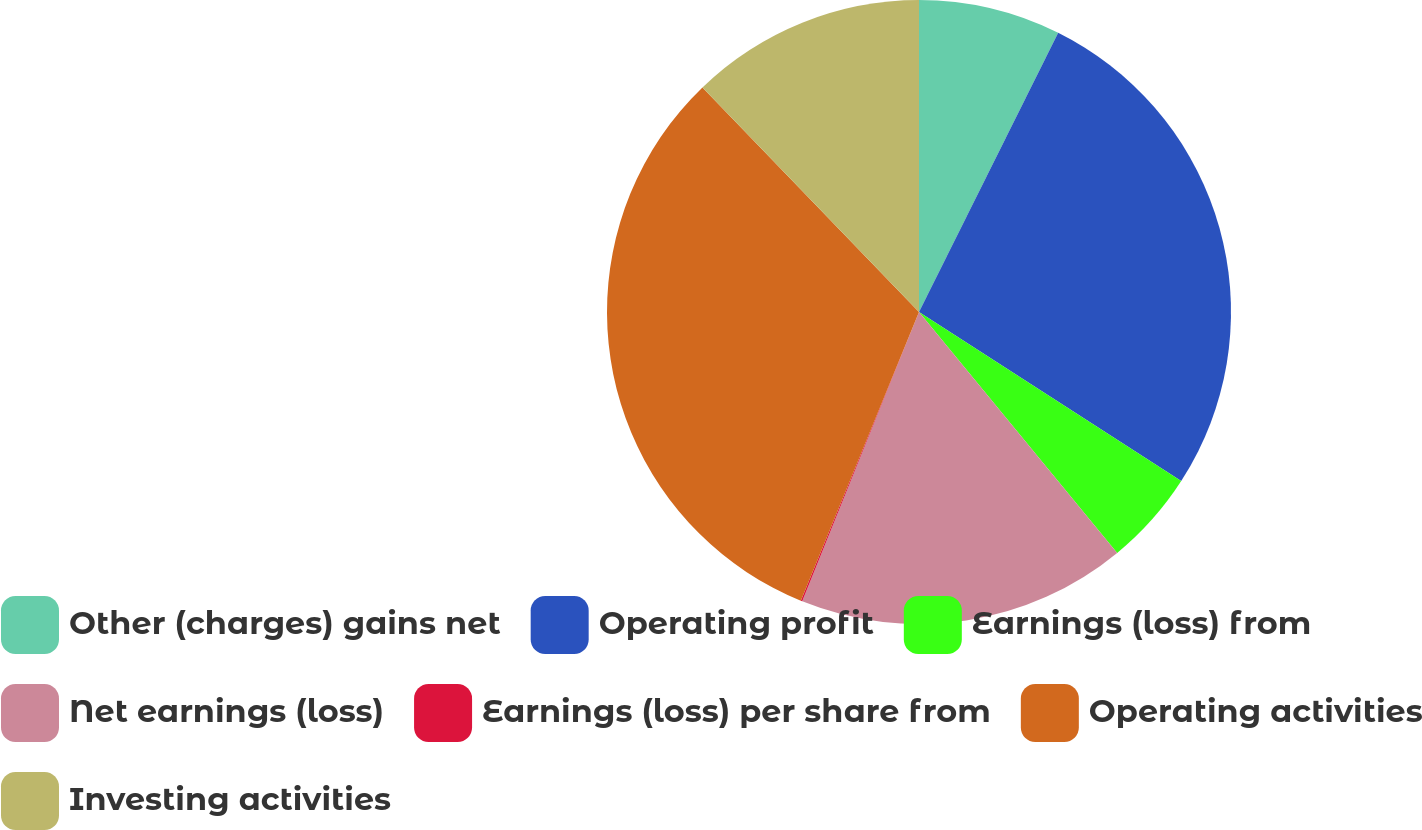<chart> <loc_0><loc_0><loc_500><loc_500><pie_chart><fcel>Other (charges) gains net<fcel>Operating profit<fcel>Earnings (loss) from<fcel>Net earnings (loss)<fcel>Earnings (loss) per share from<fcel>Operating activities<fcel>Investing activities<nl><fcel>7.36%<fcel>26.76%<fcel>4.93%<fcel>17.06%<fcel>0.08%<fcel>31.61%<fcel>12.21%<nl></chart> 